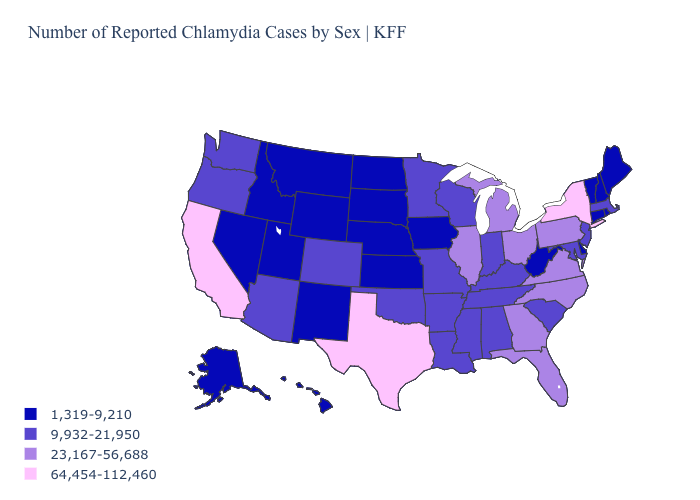Among the states that border Arizona , which have the highest value?
Write a very short answer. California. Does California have the highest value in the West?
Give a very brief answer. Yes. Does the first symbol in the legend represent the smallest category?
Concise answer only. Yes. Which states have the lowest value in the USA?
Concise answer only. Alaska, Connecticut, Delaware, Hawaii, Idaho, Iowa, Kansas, Maine, Montana, Nebraska, Nevada, New Hampshire, New Mexico, North Dakota, Rhode Island, South Dakota, Utah, Vermont, West Virginia, Wyoming. Name the states that have a value in the range 64,454-112,460?
Keep it brief. California, New York, Texas. Does Oregon have a higher value than Colorado?
Answer briefly. No. What is the highest value in the USA?
Concise answer only. 64,454-112,460. What is the value of Utah?
Be succinct. 1,319-9,210. What is the lowest value in the USA?
Concise answer only. 1,319-9,210. Does Texas have the highest value in the USA?
Be succinct. Yes. What is the lowest value in the USA?
Give a very brief answer. 1,319-9,210. Does the first symbol in the legend represent the smallest category?
Concise answer only. Yes. Does Wyoming have the lowest value in the USA?
Answer briefly. Yes. Name the states that have a value in the range 64,454-112,460?
Give a very brief answer. California, New York, Texas. What is the value of Nebraska?
Concise answer only. 1,319-9,210. 